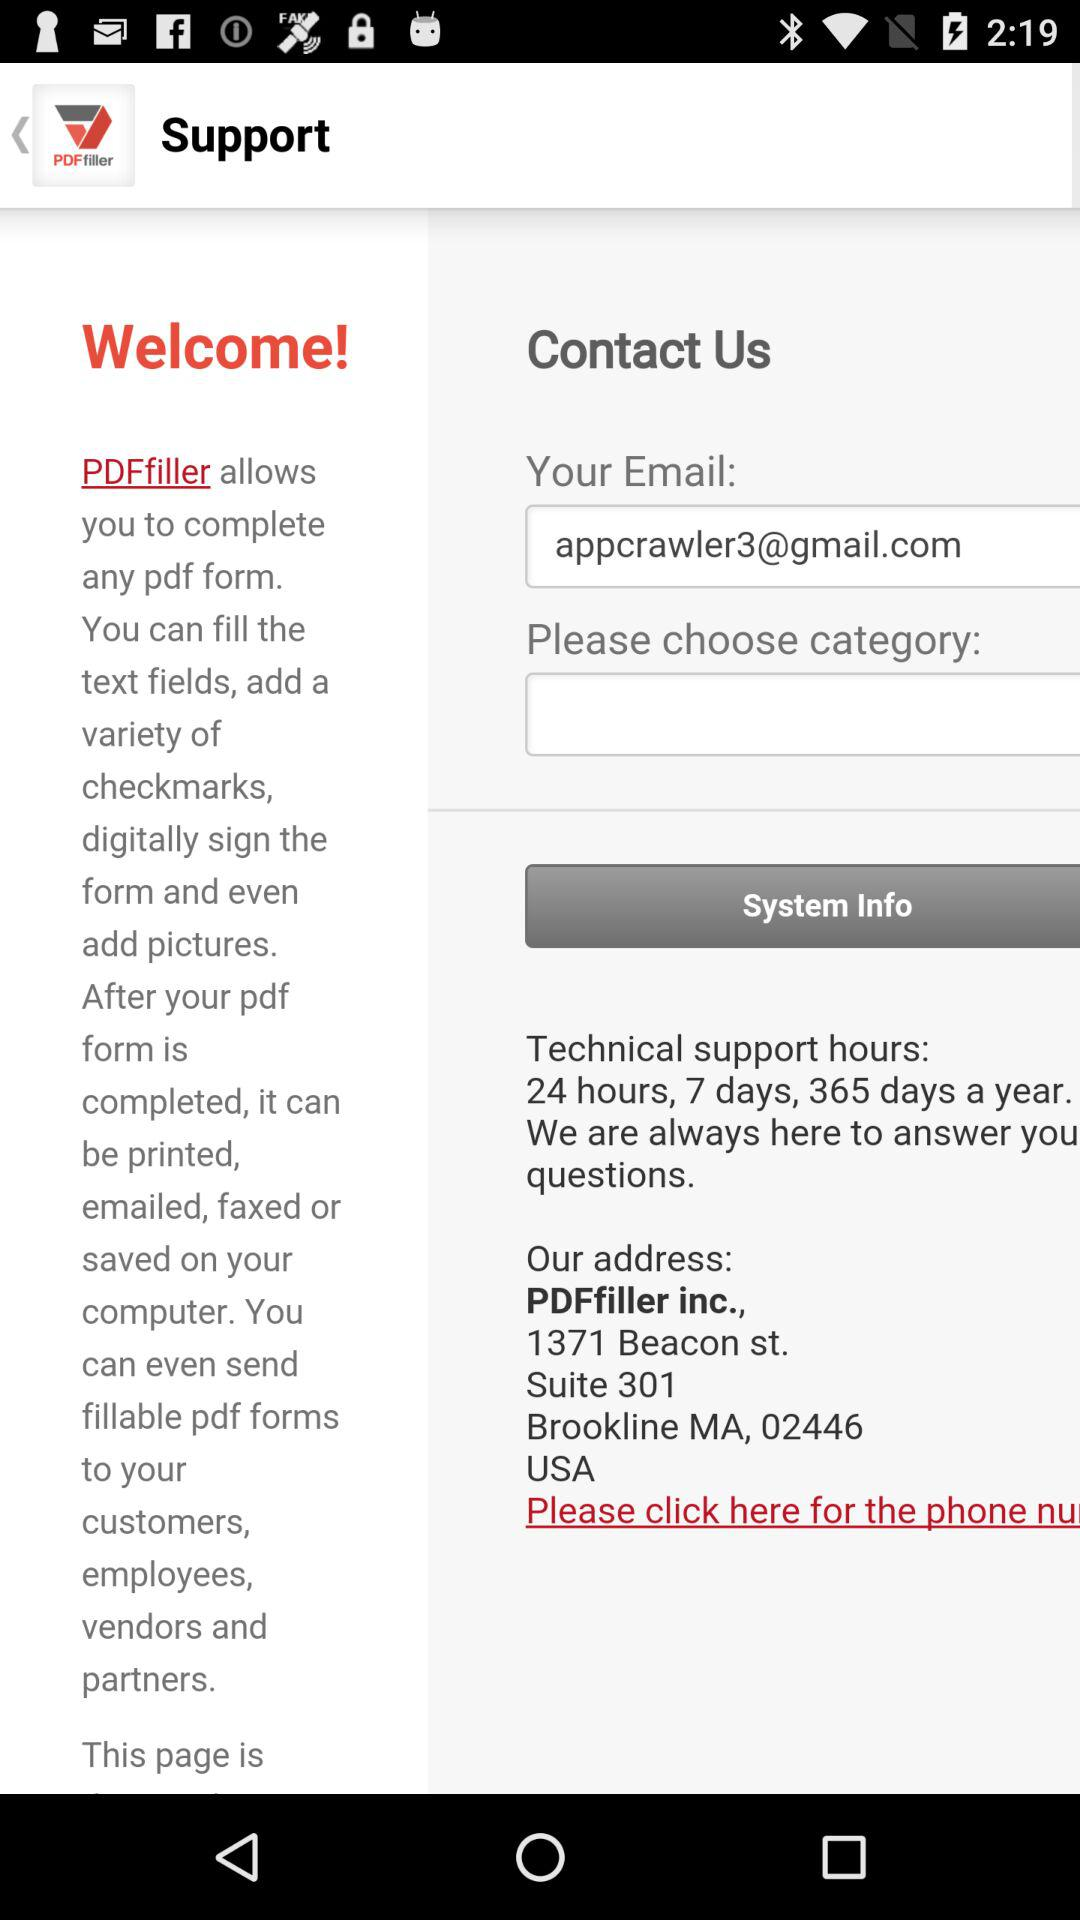When will technical support be available? Technical support will be available for 24 hours, 7 days, 365 days a year. 